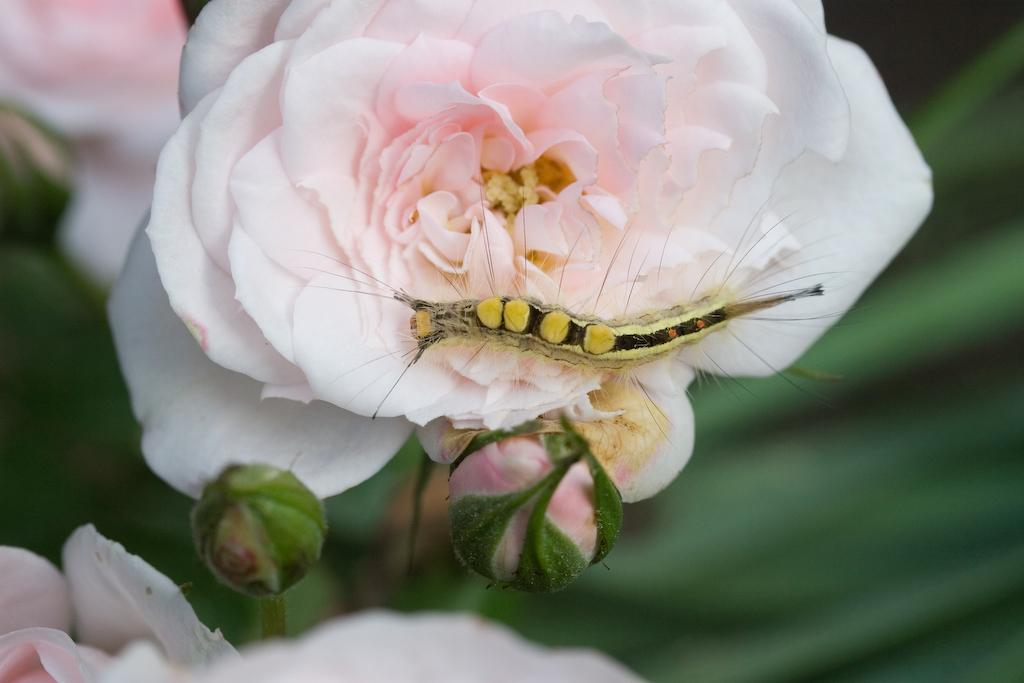What is the main subject of the image? There is an insect in the image. Where is the insect located? The insect is on a flower. What is the position of the flower in the image? The flower is in the center of the image. How would you describe the background of the image? The background of the image is blurry. What type of fire can be seen in the image? There is no fire present in the image. Is the insect causing any trouble in the image? The image does not provide any information about the insect causing trouble. 